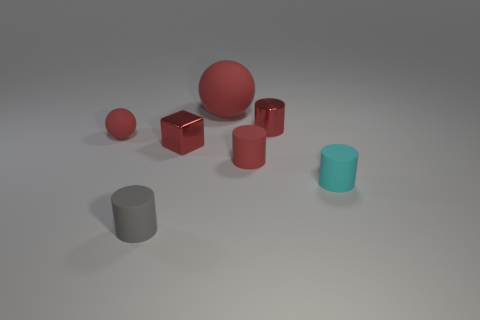Are there the same number of small red matte spheres in front of the large thing and small cylinders that are in front of the cyan matte object?
Offer a terse response. Yes. There is a small shiny thing on the left side of the cylinder behind the red rubber thing to the right of the large ball; what is its shape?
Your answer should be compact. Cube. Is the material of the ball in front of the big ball the same as the cube behind the cyan cylinder?
Make the answer very short. No. There is a tiny metal thing in front of the small matte ball; what shape is it?
Offer a terse response. Cube. Is the number of gray cylinders less than the number of cylinders?
Offer a terse response. Yes. There is a small rubber cylinder on the right side of the tiny red matte object that is to the right of the big red ball; are there any small rubber things that are in front of it?
Provide a succinct answer. Yes. What number of matte things are either red blocks or small blue things?
Make the answer very short. 0. Does the small rubber ball have the same color as the block?
Offer a very short reply. Yes. There is a tiny gray matte cylinder; what number of tiny red matte cylinders are in front of it?
Your answer should be very brief. 0. How many rubber things are in front of the red metal block and to the right of the tiny gray matte object?
Provide a short and direct response. 2. 